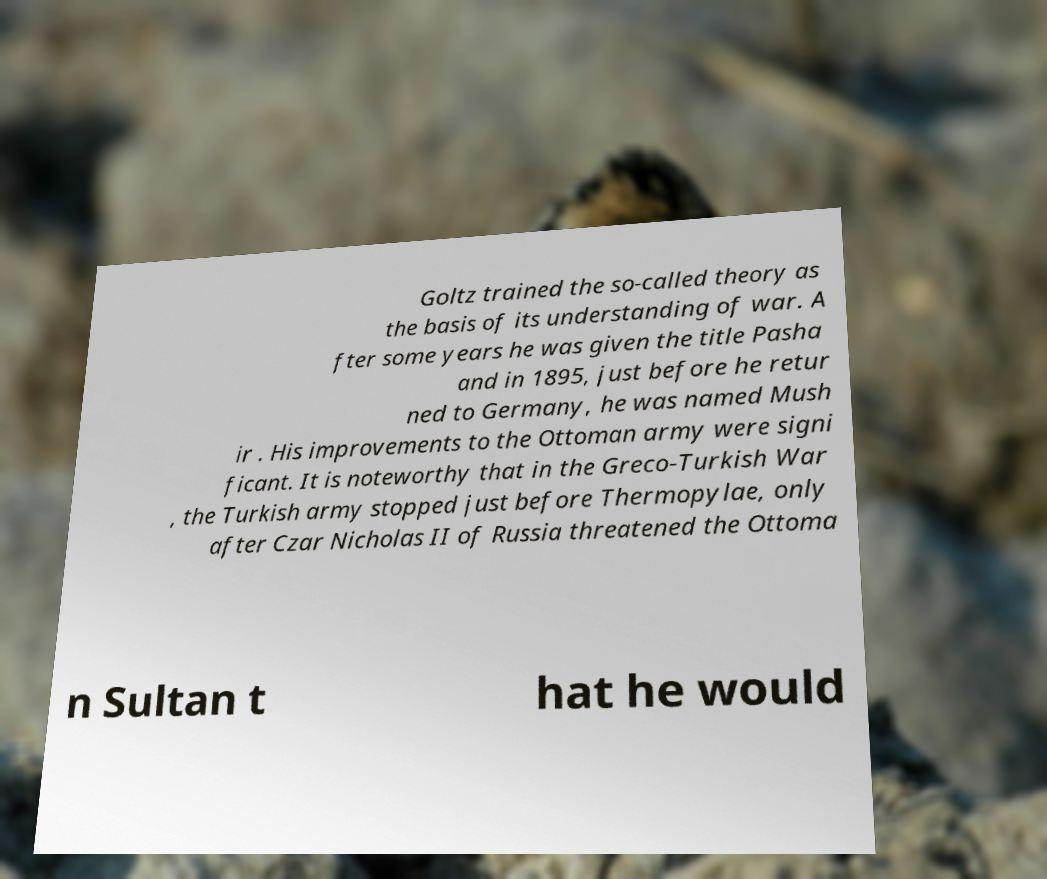Please read and relay the text visible in this image. What does it say? Goltz trained the so-called theory as the basis of its understanding of war. A fter some years he was given the title Pasha and in 1895, just before he retur ned to Germany, he was named Mush ir . His improvements to the Ottoman army were signi ficant. It is noteworthy that in the Greco-Turkish War , the Turkish army stopped just before Thermopylae, only after Czar Nicholas II of Russia threatened the Ottoma n Sultan t hat he would 